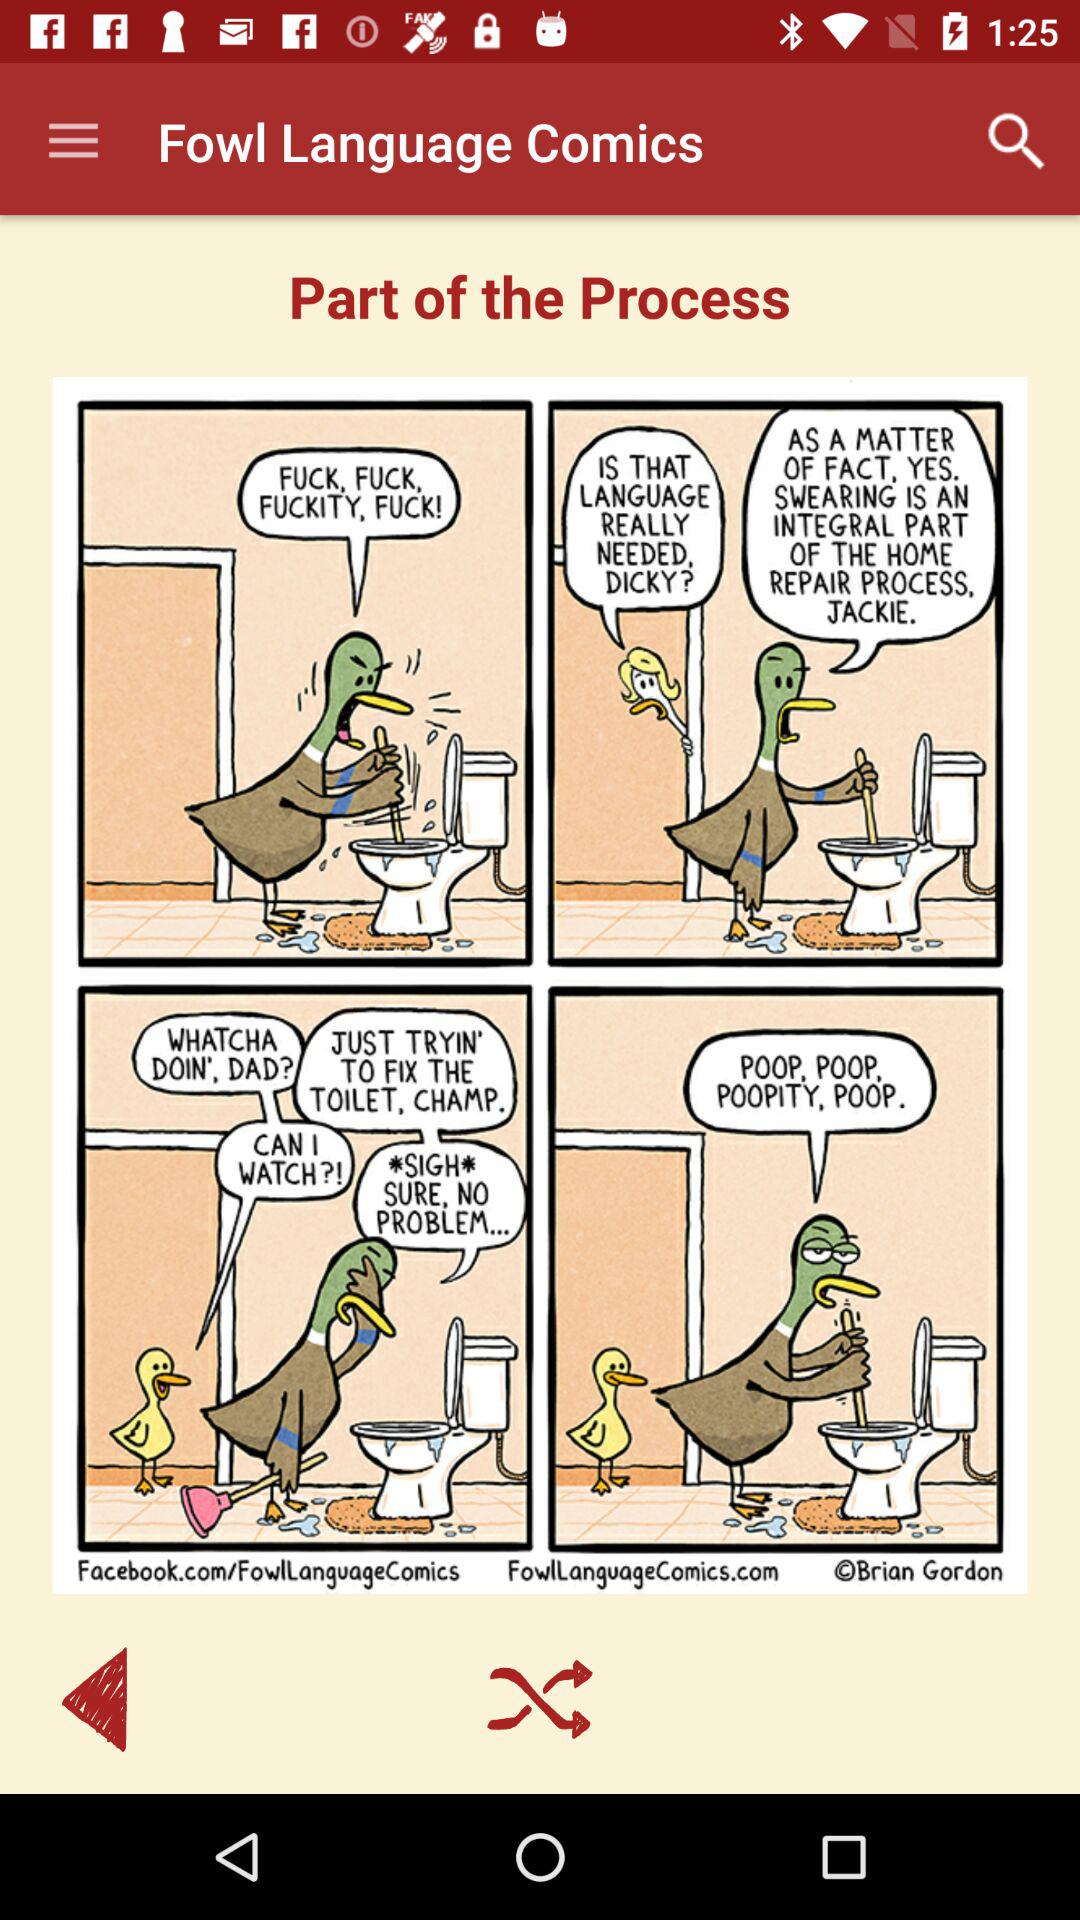What is the application name? The application name is "Fowl Language Comics". 